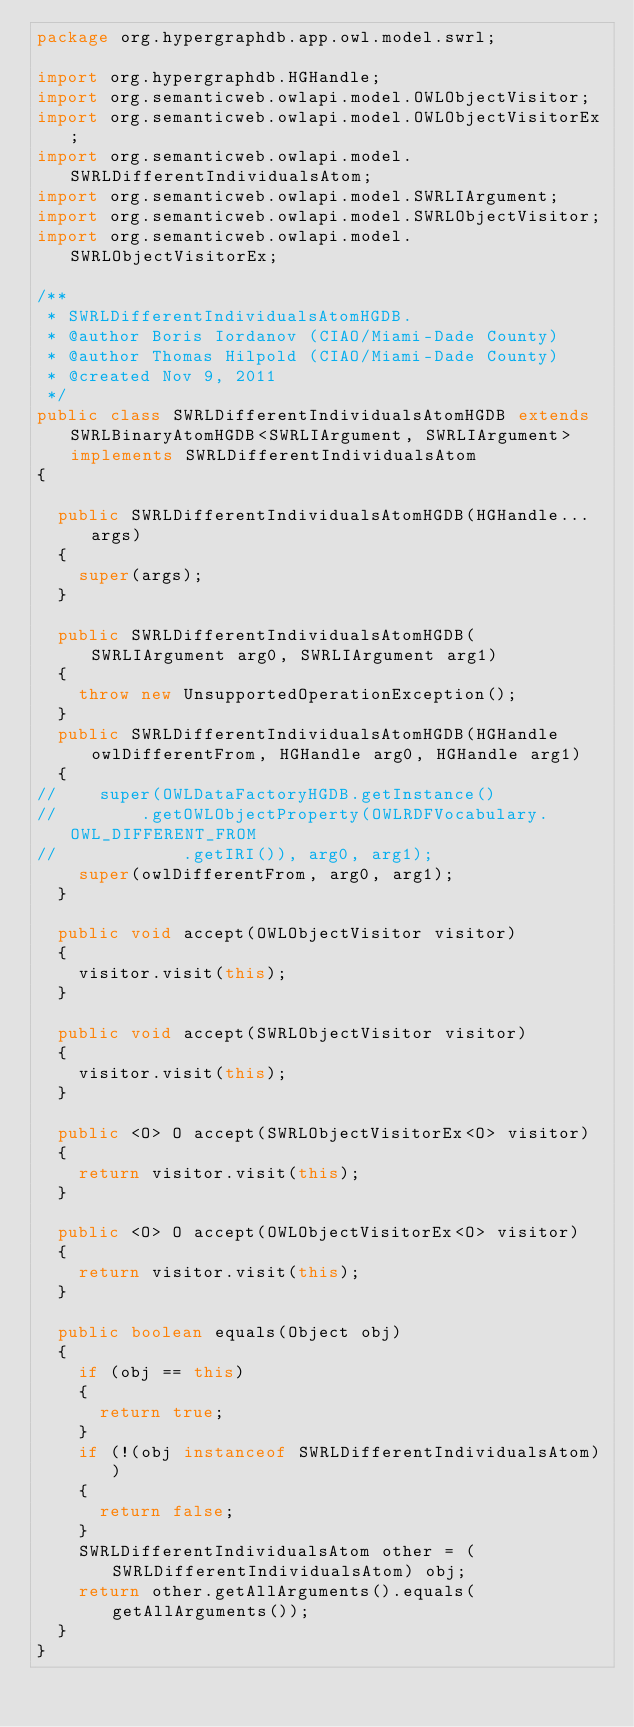<code> <loc_0><loc_0><loc_500><loc_500><_Java_>package org.hypergraphdb.app.owl.model.swrl;

import org.hypergraphdb.HGHandle;
import org.semanticweb.owlapi.model.OWLObjectVisitor;
import org.semanticweb.owlapi.model.OWLObjectVisitorEx;
import org.semanticweb.owlapi.model.SWRLDifferentIndividualsAtom;
import org.semanticweb.owlapi.model.SWRLIArgument;
import org.semanticweb.owlapi.model.SWRLObjectVisitor;
import org.semanticweb.owlapi.model.SWRLObjectVisitorEx;

/**
 * SWRLDifferentIndividualsAtomHGDB.
 * @author Boris Iordanov (CIAO/Miami-Dade County)
 * @author Thomas Hilpold (CIAO/Miami-Dade County)
 * @created Nov 9, 2011
 */
public class SWRLDifferentIndividualsAtomHGDB extends SWRLBinaryAtomHGDB<SWRLIArgument, SWRLIArgument> implements SWRLDifferentIndividualsAtom
{
	
	public SWRLDifferentIndividualsAtomHGDB(HGHandle... args)
	{
		super(args);
	}

	public SWRLDifferentIndividualsAtomHGDB(SWRLIArgument arg0, SWRLIArgument arg1)
	{
		throw new UnsupportedOperationException();
	}
	public SWRLDifferentIndividualsAtomHGDB(HGHandle owlDifferentFrom, HGHandle arg0, HGHandle arg1)
	{
//		super(OWLDataFactoryHGDB.getInstance()
//				.getOWLObjectProperty(OWLRDFVocabulary.OWL_DIFFERENT_FROM
//						.getIRI()), arg0, arg1);
		super(owlDifferentFrom, arg0, arg1);
	}
	
	public void accept(OWLObjectVisitor visitor)
	{
		visitor.visit(this);
	}

	public void accept(SWRLObjectVisitor visitor)
	{
		visitor.visit(this);
	}

	public <O> O accept(SWRLObjectVisitorEx<O> visitor)
	{
		return visitor.visit(this);
	}

	public <O> O accept(OWLObjectVisitorEx<O> visitor)
	{
		return visitor.visit(this);
	}

	public boolean equals(Object obj)
	{
		if (obj == this)
		{
			return true;
		}
		if (!(obj instanceof SWRLDifferentIndividualsAtom))
		{
			return false;
		}
		SWRLDifferentIndividualsAtom other = (SWRLDifferentIndividualsAtom) obj;
		return other.getAllArguments().equals(getAllArguments());
	}
}</code> 